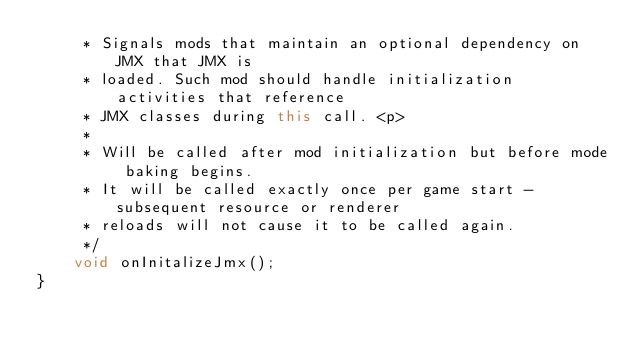<code> <loc_0><loc_0><loc_500><loc_500><_Java_>     * Signals mods that maintain an optional dependency on JMX that JMX is
     * loaded. Such mod should handle initialization activities that reference
     * JMX classes during this call. <p>
     * 
     * Will be called after mod initialization but before mode baking begins.
     * It will be called exactly once per game start - subsequent resource or renderer
     * reloads will not cause it to be called again.
     */
    void onInitalizeJmx();
}
</code> 